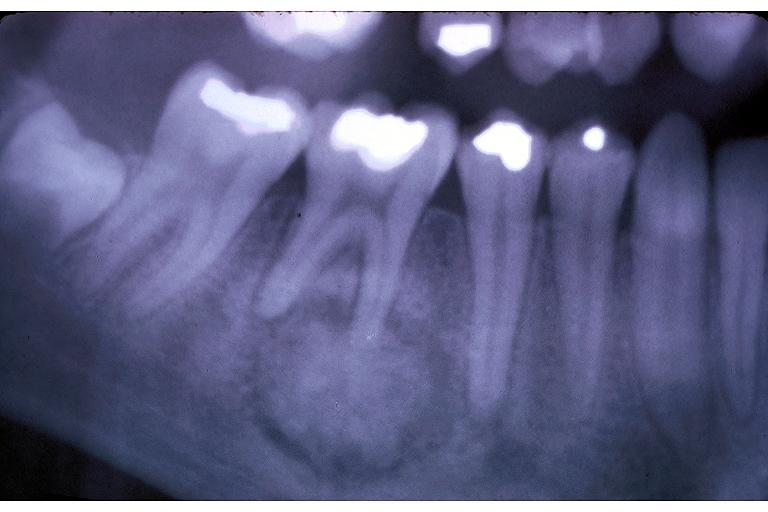s oral present?
Answer the question using a single word or phrase. Yes 